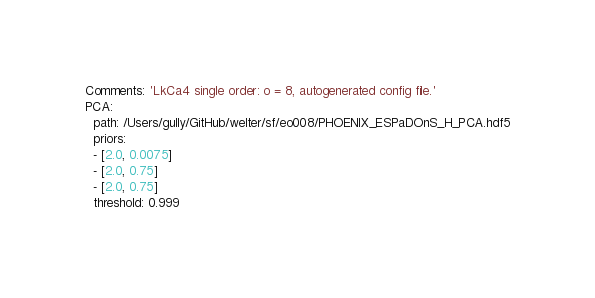Convert code to text. <code><loc_0><loc_0><loc_500><loc_500><_YAML_>Comments: 'LkCa4 single order: o = 8, autogenerated config file.'
PCA:
  path: /Users/gully/GitHub/welter/sf/eo008/PHOENIX_ESPaDOnS_H_PCA.hdf5
  priors:
  - [2.0, 0.0075]
  - [2.0, 0.75]
  - [2.0, 0.75]
  threshold: 0.999</code> 